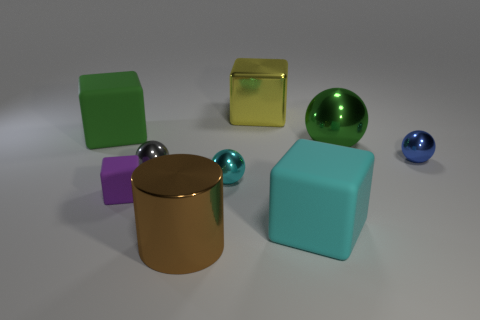Is there anything else that has the same shape as the large brown object?
Provide a short and direct response. No. There is a brown thing that is the same size as the yellow cube; what is its shape?
Make the answer very short. Cylinder. Is there a cylinder of the same size as the cyan rubber block?
Offer a terse response. Yes. What is the material of the purple block that is the same size as the gray thing?
Provide a short and direct response. Rubber. How big is the cyan object behind the big matte object that is in front of the tiny purple matte cube?
Provide a succinct answer. Small. Do the matte cube left of the purple rubber object and the gray metallic sphere have the same size?
Give a very brief answer. No. Is the number of big blocks that are behind the blue object greater than the number of small objects that are behind the small cyan ball?
Provide a succinct answer. No. What shape is the large object that is both behind the large cyan object and right of the big yellow thing?
Provide a succinct answer. Sphere. The green object that is to the left of the large yellow shiny thing has what shape?
Offer a very short reply. Cube. There is a object that is in front of the big rubber thing in front of the big object left of the large brown thing; how big is it?
Your response must be concise. Large. 